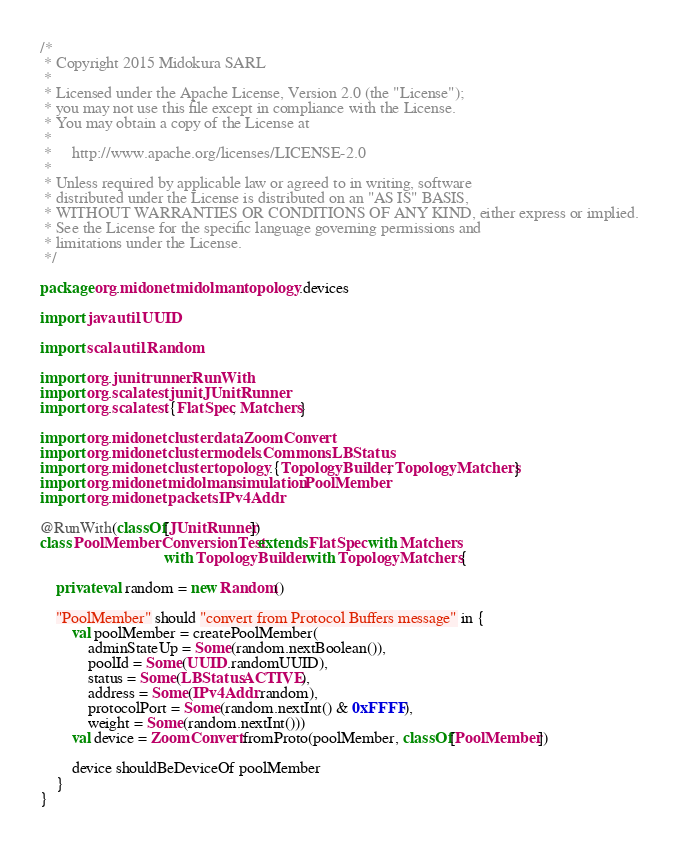<code> <loc_0><loc_0><loc_500><loc_500><_Scala_>/*
 * Copyright 2015 Midokura SARL
 *
 * Licensed under the Apache License, Version 2.0 (the "License");
 * you may not use this file except in compliance with the License.
 * You may obtain a copy of the License at
 *
 *     http://www.apache.org/licenses/LICENSE-2.0
 *
 * Unless required by applicable law or agreed to in writing, software
 * distributed under the License is distributed on an "AS IS" BASIS,
 * WITHOUT WARRANTIES OR CONDITIONS OF ANY KIND, either express or implied.
 * See the License for the specific language governing permissions and
 * limitations under the License.
 */

package org.midonet.midolman.topology.devices

import java.util.UUID

import scala.util.Random

import org.junit.runner.RunWith
import org.scalatest.junit.JUnitRunner
import org.scalatest.{FlatSpec, Matchers}

import org.midonet.cluster.data.ZoomConvert
import org.midonet.cluster.models.Commons.LBStatus
import org.midonet.cluster.topology.{TopologyBuilder, TopologyMatchers}
import org.midonet.midolman.simulation.PoolMember
import org.midonet.packets.IPv4Addr

@RunWith(classOf[JUnitRunner])
class PoolMemberConversionTest extends FlatSpec with Matchers
                               with TopologyBuilder with TopologyMatchers {

    private val random = new Random()

    "PoolMember" should "convert from Protocol Buffers message" in {
        val poolMember = createPoolMember(
            adminStateUp = Some(random.nextBoolean()),
            poolId = Some(UUID.randomUUID),
            status = Some(LBStatus.ACTIVE),
            address = Some(IPv4Addr.random),
            protocolPort = Some(random.nextInt() & 0xFFFF),
            weight = Some(random.nextInt()))
        val device = ZoomConvert.fromProto(poolMember, classOf[PoolMember])

        device shouldBeDeviceOf poolMember
    }
}
</code> 